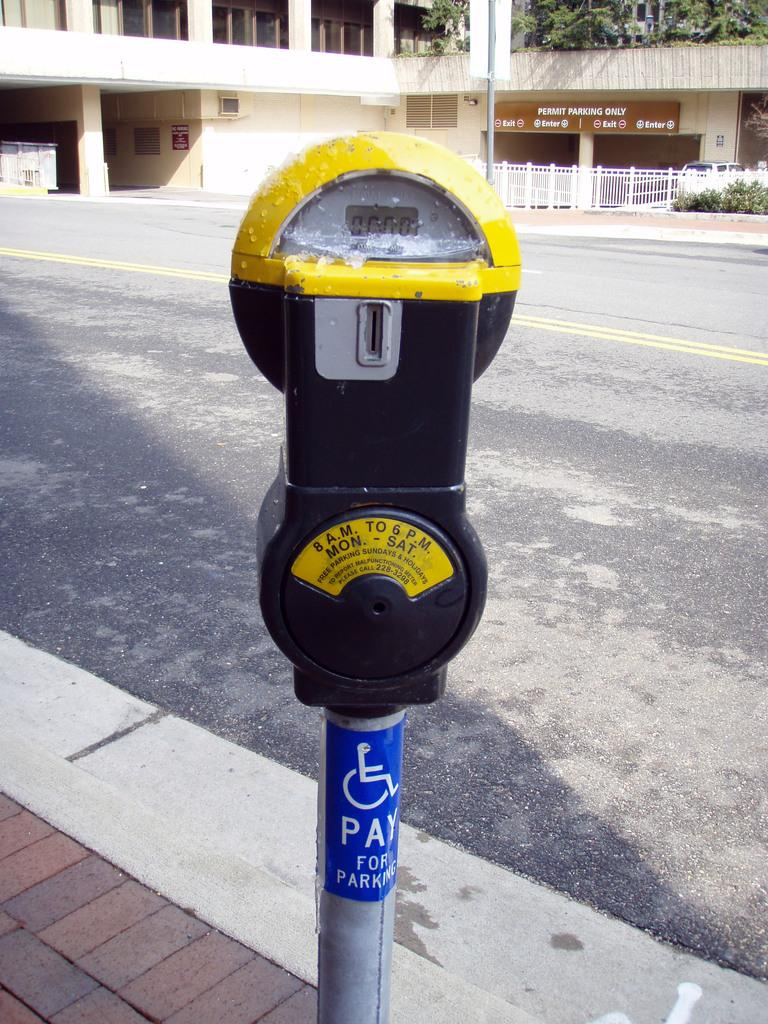<image>
Share a concise interpretation of the image provided. A parking meter that can be operated from 8am-6pm. 